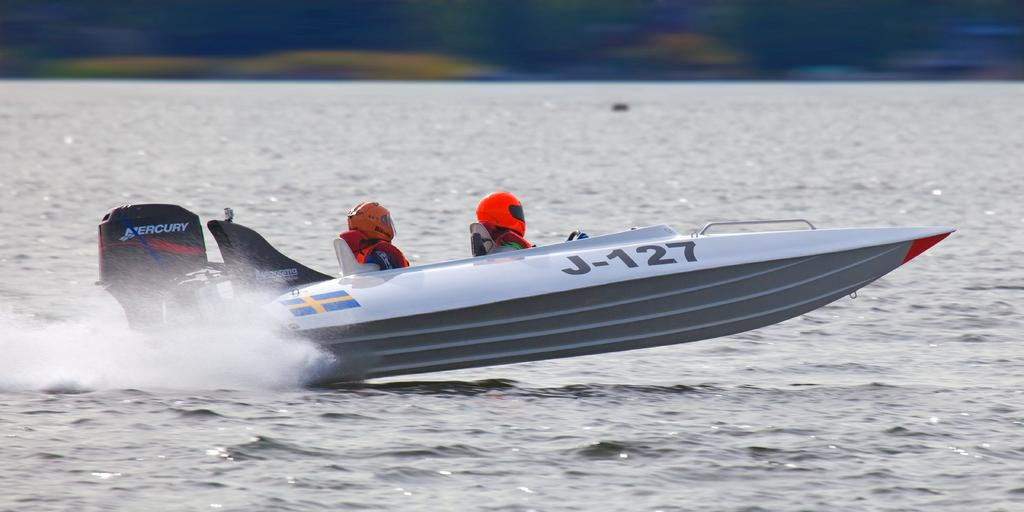<image>
Summarize the visual content of the image. Two people are wearing helmets while in a speed boat with the ID J-127 painted on the side. 